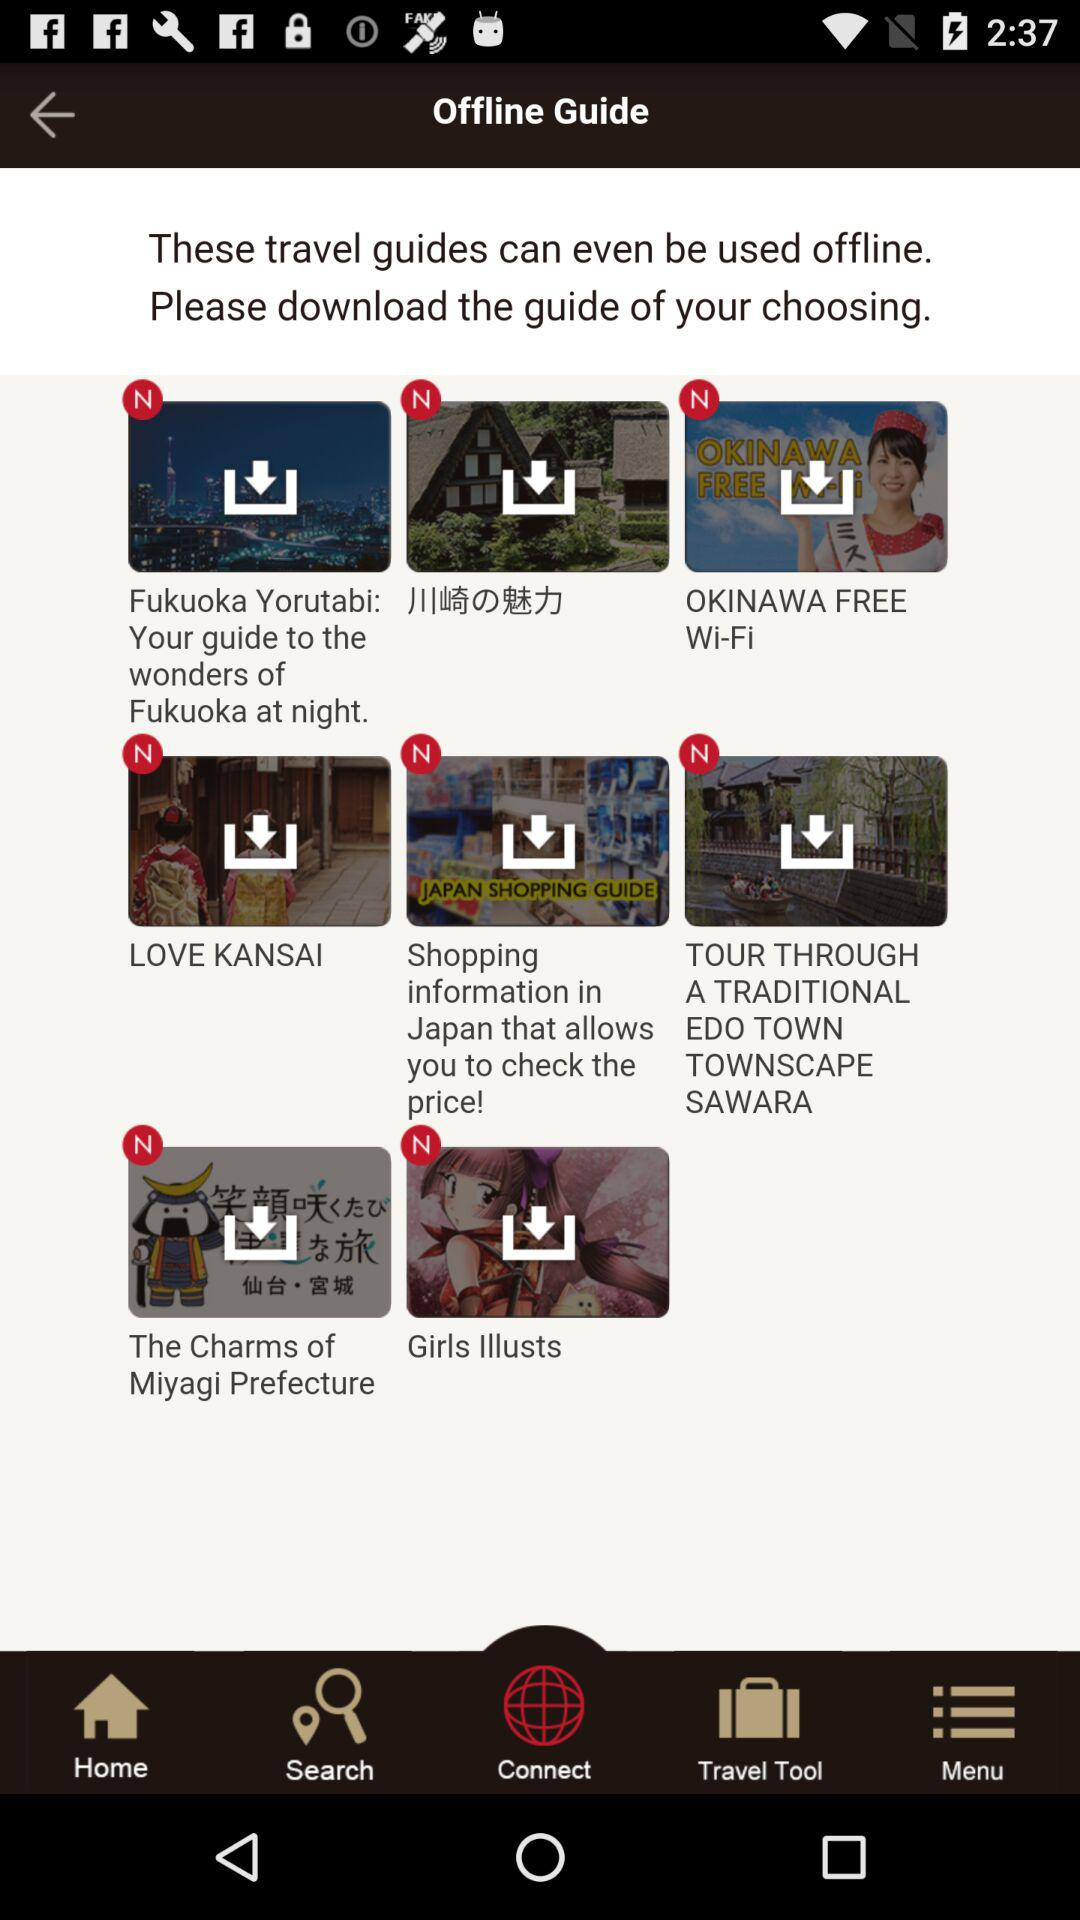How many guides are there in total?
Answer the question using a single word or phrase. 8 